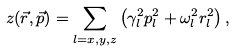<formula> <loc_0><loc_0><loc_500><loc_500>z ( \vec { r } , \vec { p } ) = \sum _ { l = x , y , z } \left ( \gamma _ { l } ^ { 2 } p _ { l } ^ { 2 } + \omega _ { l } ^ { 2 } r _ { l } ^ { 2 } \right ) ,</formula> 